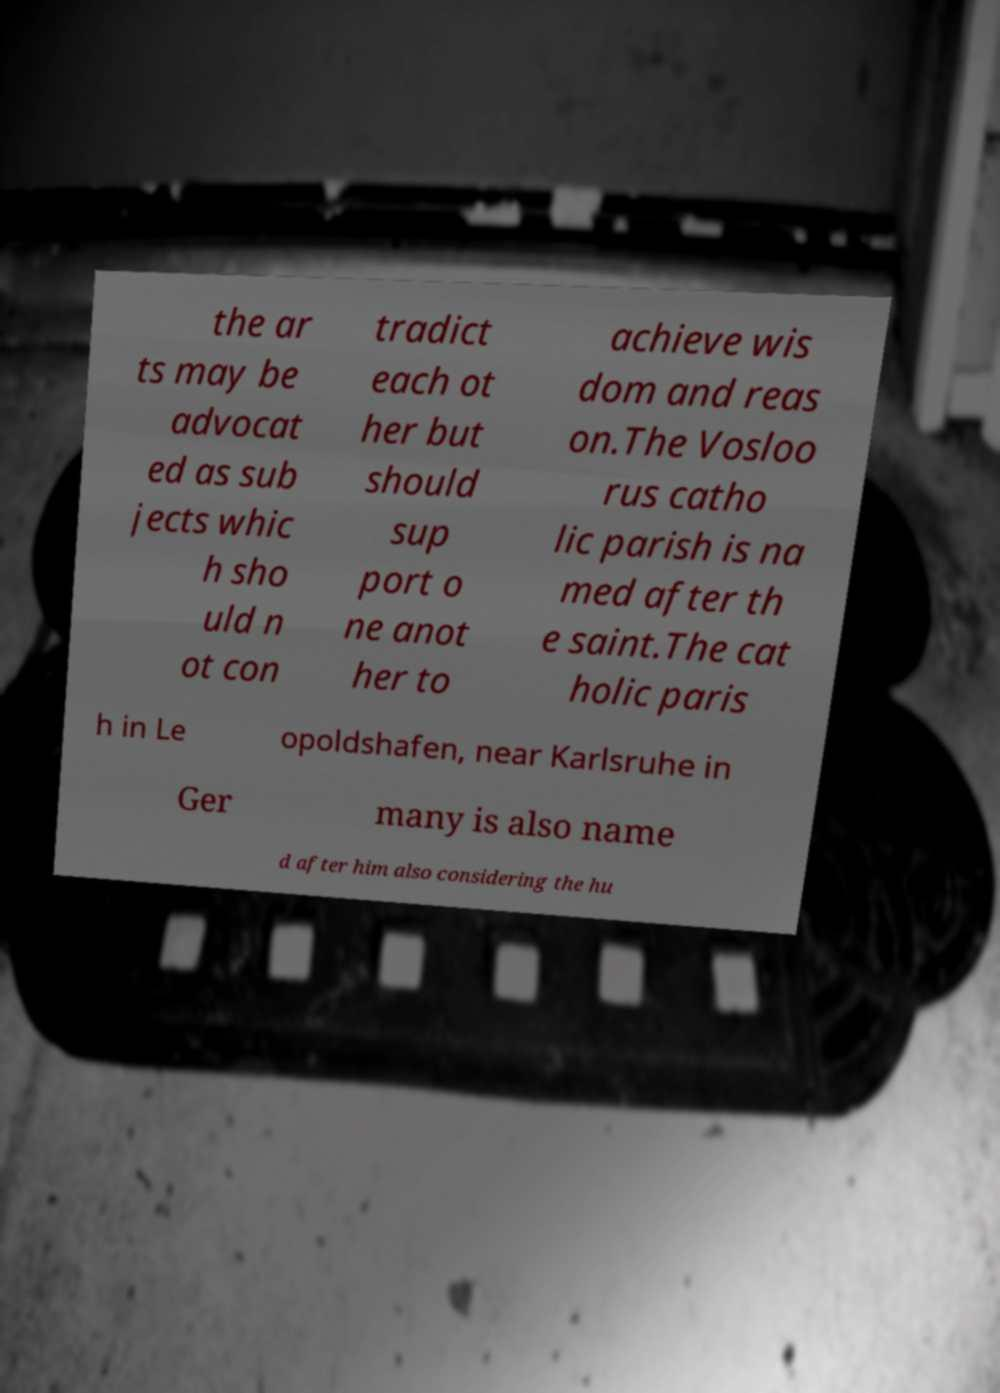Could you assist in decoding the text presented in this image and type it out clearly? the ar ts may be advocat ed as sub jects whic h sho uld n ot con tradict each ot her but should sup port o ne anot her to achieve wis dom and reas on.The Vosloo rus catho lic parish is na med after th e saint.The cat holic paris h in Le opoldshafen, near Karlsruhe in Ger many is also name d after him also considering the hu 